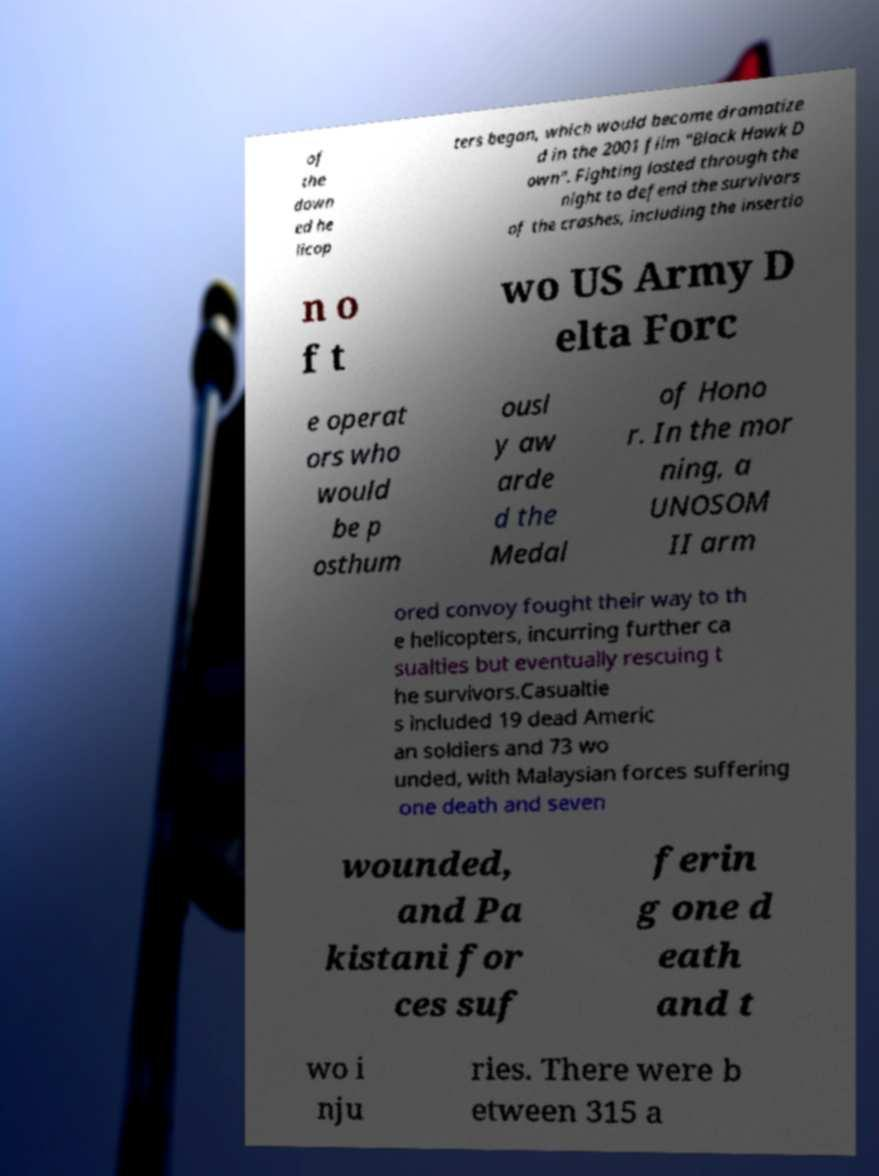Can you accurately transcribe the text from the provided image for me? of the down ed he licop ters began, which would become dramatize d in the 2001 film "Black Hawk D own". Fighting lasted through the night to defend the survivors of the crashes, including the insertio n o f t wo US Army D elta Forc e operat ors who would be p osthum ousl y aw arde d the Medal of Hono r. In the mor ning, a UNOSOM II arm ored convoy fought their way to th e helicopters, incurring further ca sualties but eventually rescuing t he survivors.Casualtie s included 19 dead Americ an soldiers and 73 wo unded, with Malaysian forces suffering one death and seven wounded, and Pa kistani for ces suf ferin g one d eath and t wo i nju ries. There were b etween 315 a 